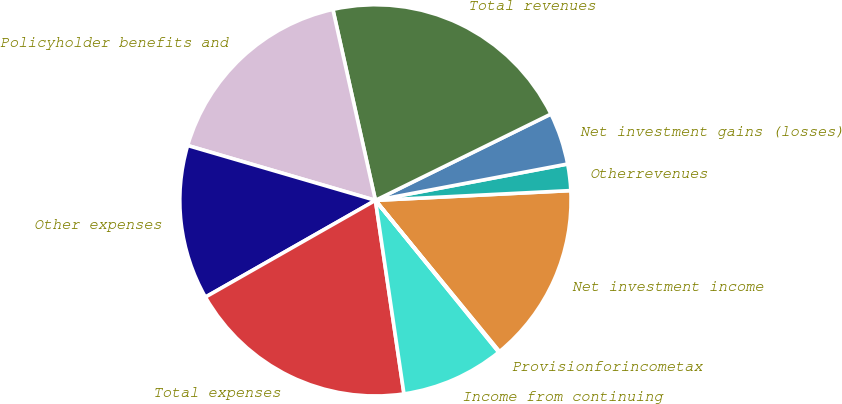Convert chart. <chart><loc_0><loc_0><loc_500><loc_500><pie_chart><fcel>Net investment income<fcel>Otherrevenues<fcel>Net investment gains (losses)<fcel>Total revenues<fcel>Policyholder benefits and<fcel>Other expenses<fcel>Total expenses<fcel>Income from continuing<fcel>Provisionforincometax<nl><fcel>14.87%<fcel>2.18%<fcel>4.3%<fcel>21.22%<fcel>16.99%<fcel>12.76%<fcel>19.1%<fcel>8.53%<fcel>0.07%<nl></chart> 